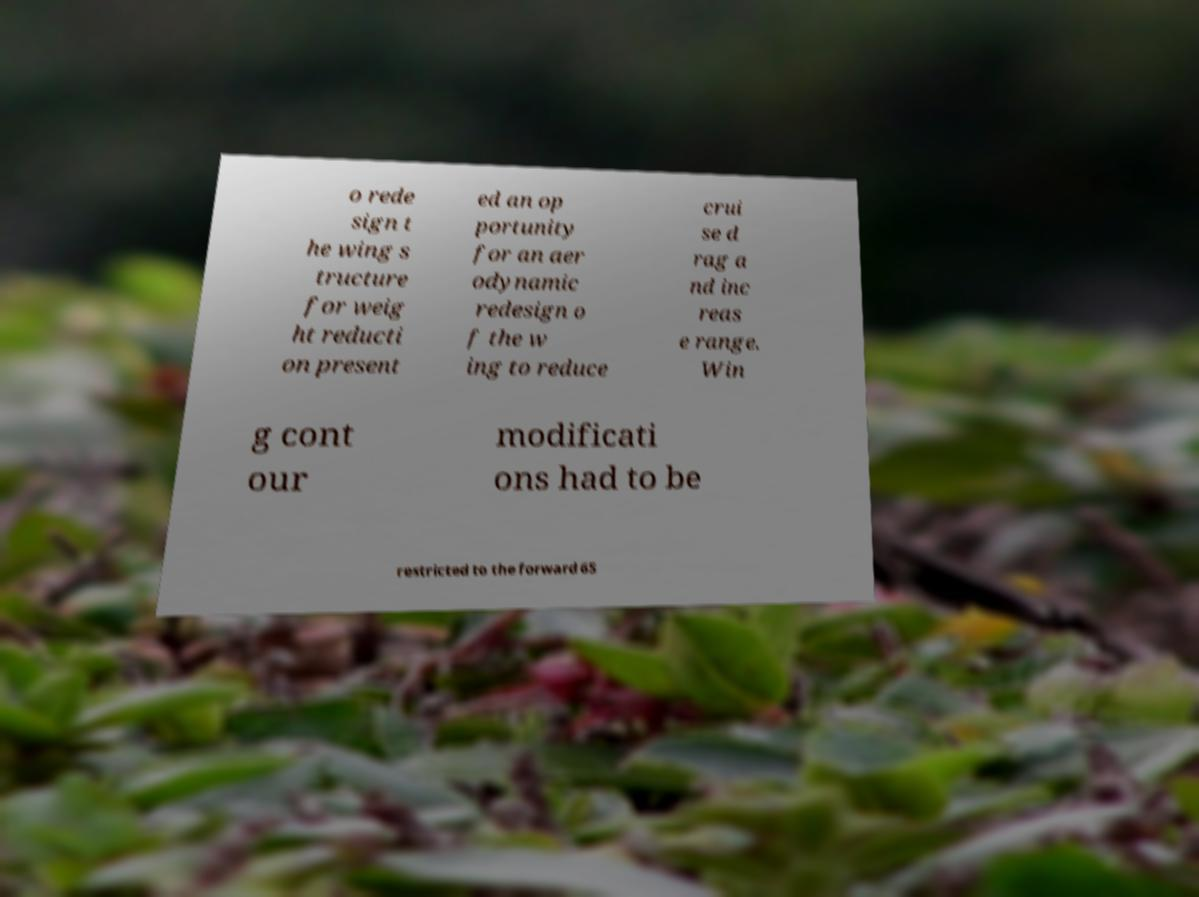Please read and relay the text visible in this image. What does it say? o rede sign t he wing s tructure for weig ht reducti on present ed an op portunity for an aer odynamic redesign o f the w ing to reduce crui se d rag a nd inc reas e range. Win g cont our modificati ons had to be restricted to the forward 65 